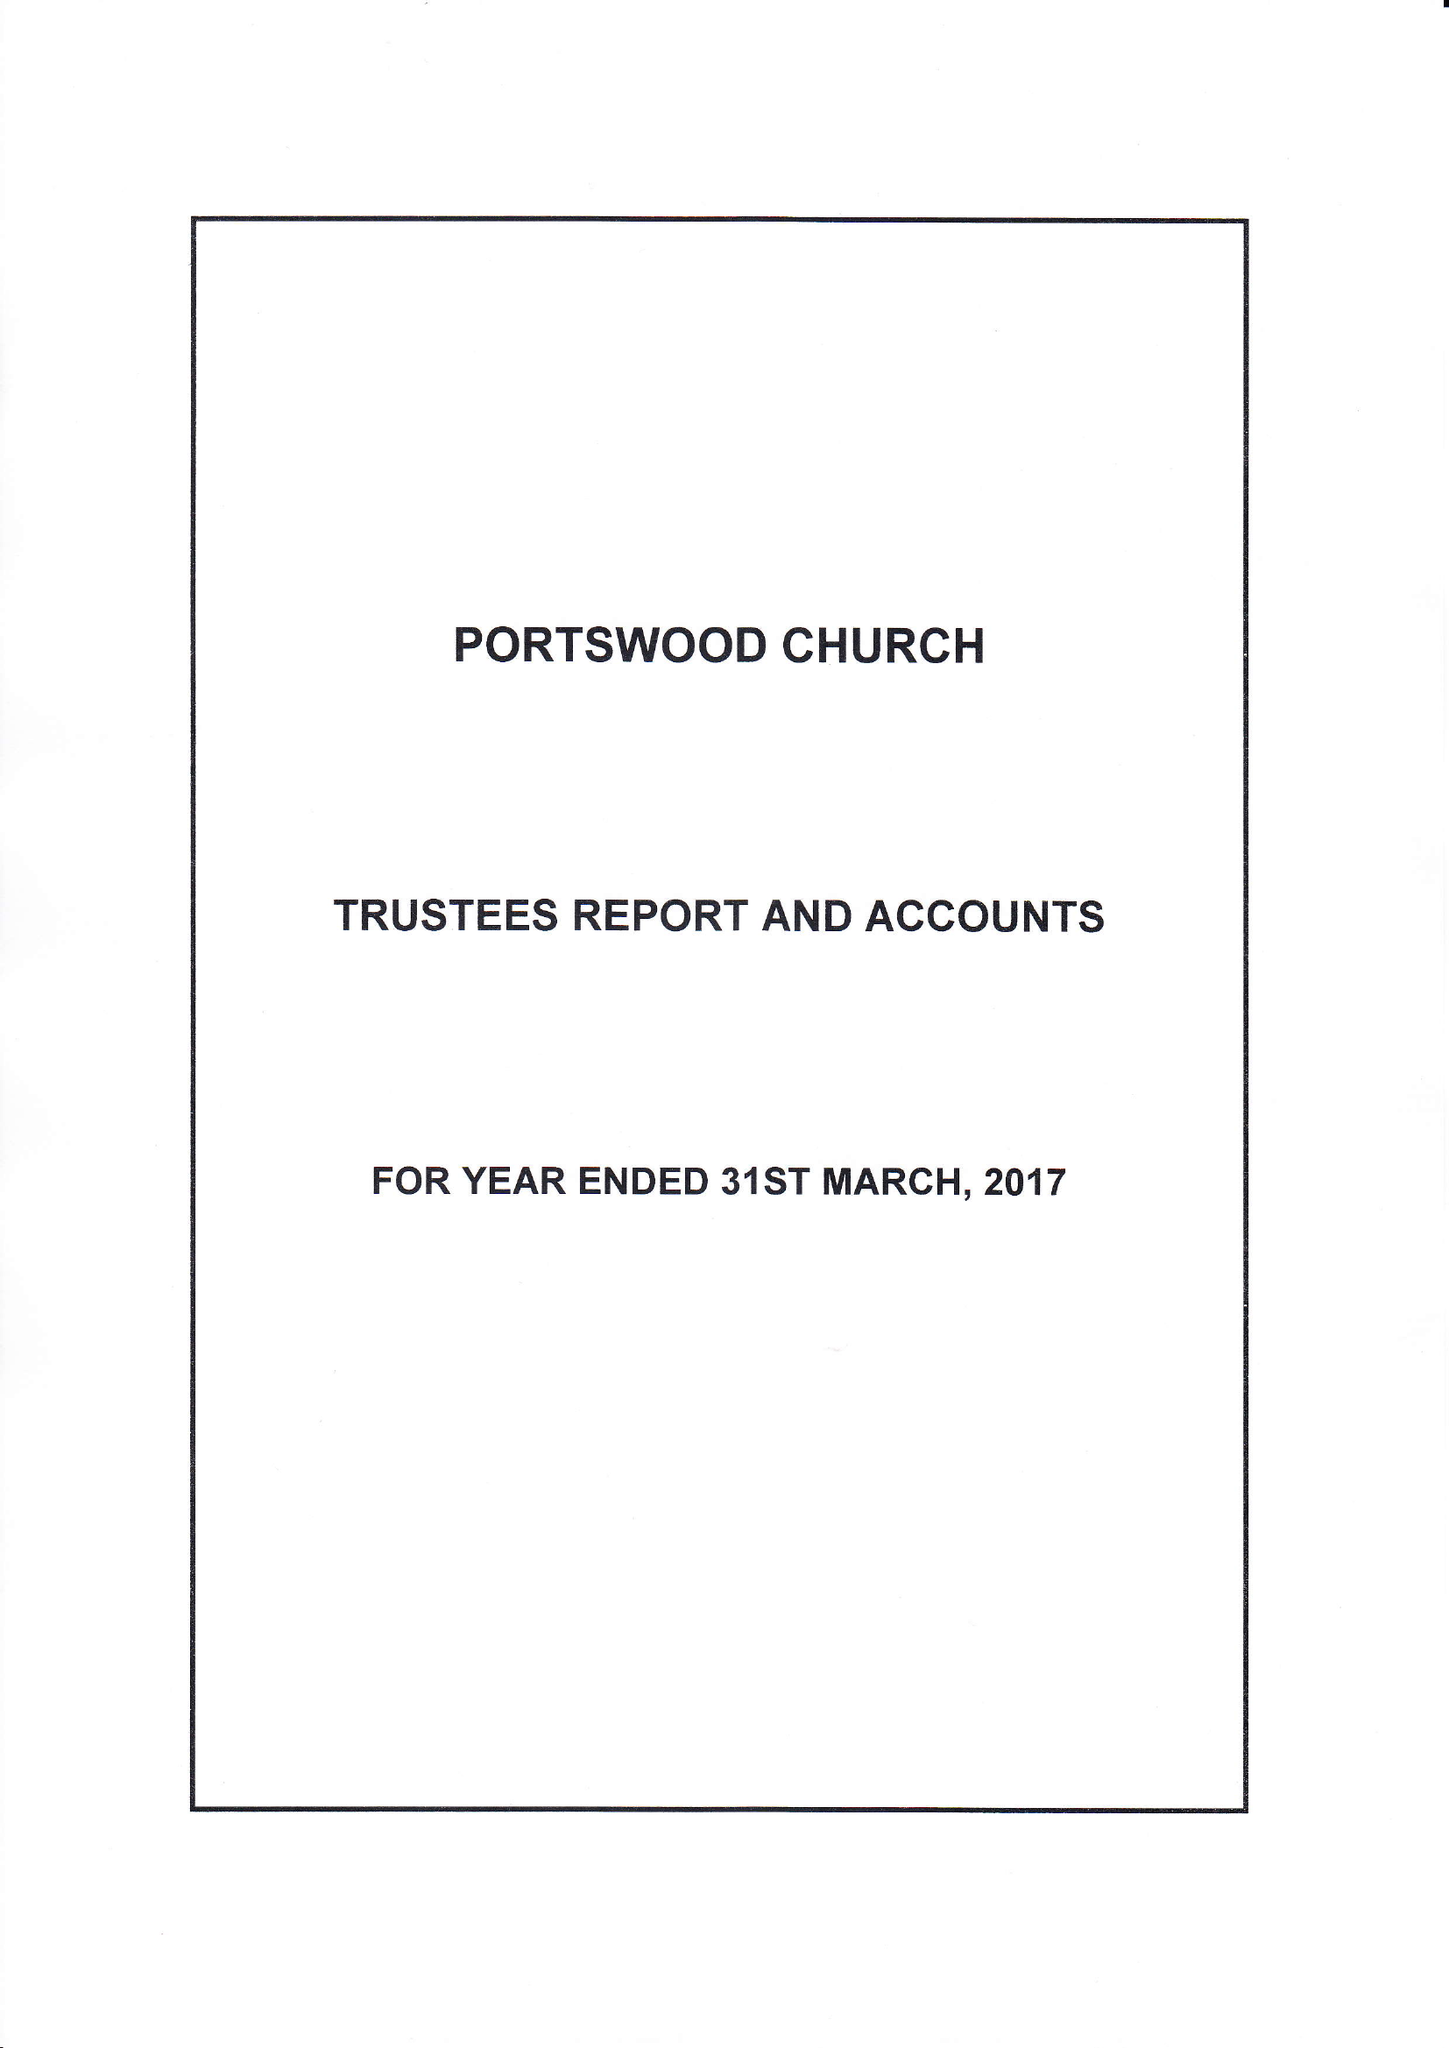What is the value for the charity_name?
Answer the question using a single word or phrase. Portswood Church 